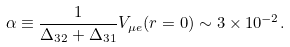Convert formula to latex. <formula><loc_0><loc_0><loc_500><loc_500>\alpha \equiv \frac { 1 } { \Delta _ { 3 2 } + \Delta _ { 3 1 } } V _ { \mu e } ( r = 0 ) \sim 3 \times 1 0 ^ { - 2 } .</formula> 